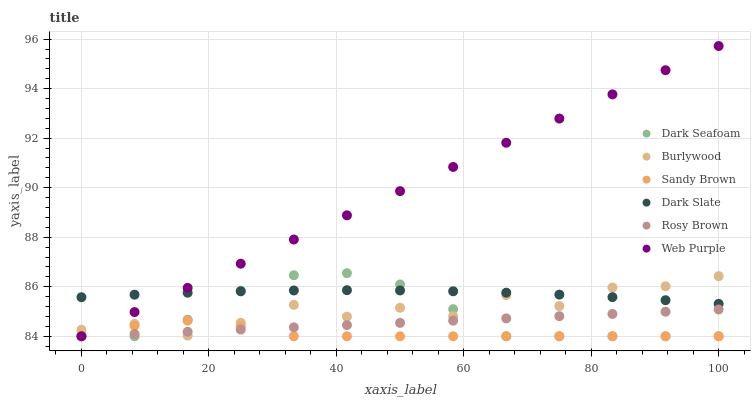Does Sandy Brown have the minimum area under the curve?
Answer yes or no. Yes. Does Web Purple have the maximum area under the curve?
Answer yes or no. Yes. Does Rosy Brown have the minimum area under the curve?
Answer yes or no. No. Does Rosy Brown have the maximum area under the curve?
Answer yes or no. No. Is Web Purple the smoothest?
Answer yes or no. Yes. Is Burlywood the roughest?
Answer yes or no. Yes. Is Rosy Brown the smoothest?
Answer yes or no. No. Is Rosy Brown the roughest?
Answer yes or no. No. Does Rosy Brown have the lowest value?
Answer yes or no. Yes. Does Dark Slate have the lowest value?
Answer yes or no. No. Does Web Purple have the highest value?
Answer yes or no. Yes. Does Rosy Brown have the highest value?
Answer yes or no. No. Is Sandy Brown less than Dark Slate?
Answer yes or no. Yes. Is Dark Slate greater than Sandy Brown?
Answer yes or no. Yes. Does Burlywood intersect Dark Slate?
Answer yes or no. Yes. Is Burlywood less than Dark Slate?
Answer yes or no. No. Is Burlywood greater than Dark Slate?
Answer yes or no. No. Does Sandy Brown intersect Dark Slate?
Answer yes or no. No. 